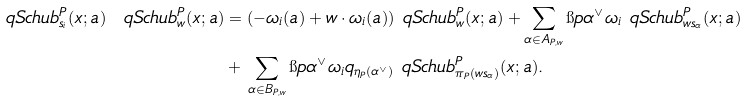<formula> <loc_0><loc_0><loc_500><loc_500>\ q S c h u b ^ { P } _ { s _ { i } } ( x ; a ) \ q S c h u b _ { w } ^ { P } ( x ; a ) & = ( - \omega _ { i } ( a ) + w \cdot \omega _ { i } ( a ) ) \ q S c h u b _ { w } ^ { P } ( x ; a ) + \sum _ { \alpha \in A _ { P , w } } \i p { \alpha ^ { \vee } } { \omega _ { i } } \ q S c h u b _ { w s _ { \alpha } } ^ { P } ( x ; a ) \\ & + \, \sum _ { \alpha \in B _ { P , w } } \i p { \alpha ^ { \vee } } { \omega _ { i } } q _ { \eta _ { P } ( \alpha ^ { \vee } ) } \ q S c h u b _ { \pi _ { P } ( w s _ { \alpha } ) } ^ { P } ( x ; a ) .</formula> 